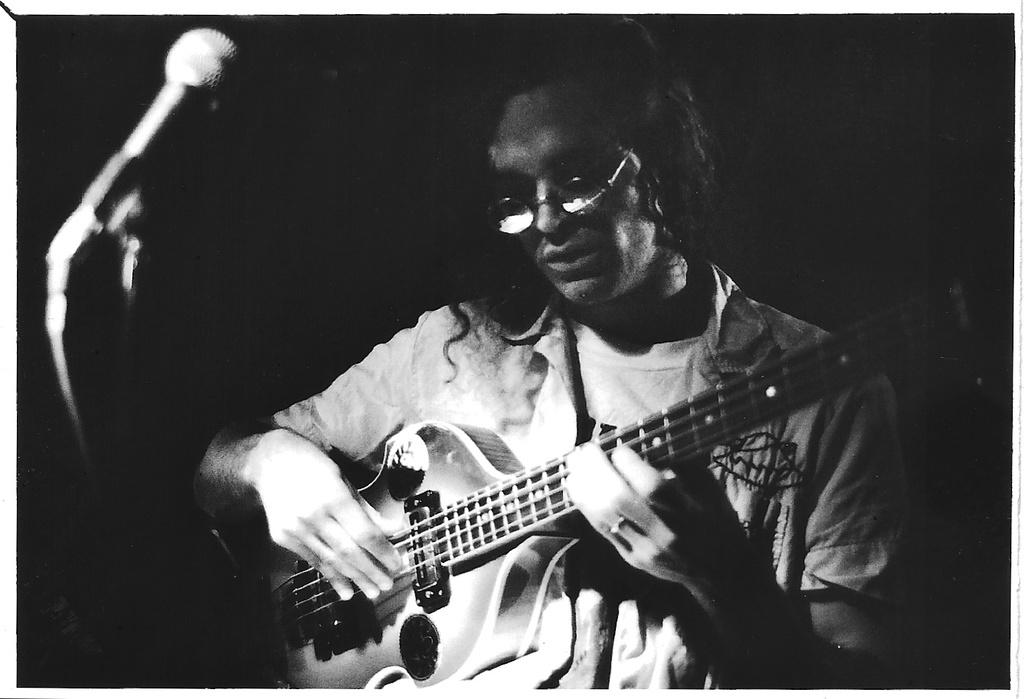What is the color scheme of the image? The image is black and white. Who is present in the image? There is a man in the image. What is the man wearing? The man is wearing spectacles. What is the man doing in the image? The man is playing a guitar and standing in front of a microphone. Can you see any eggs in the image? There are no eggs present in the image. Is the queen in the image? There is no reference to a queen or any royal figure in the image. 